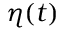<formula> <loc_0><loc_0><loc_500><loc_500>\eta ( t )</formula> 